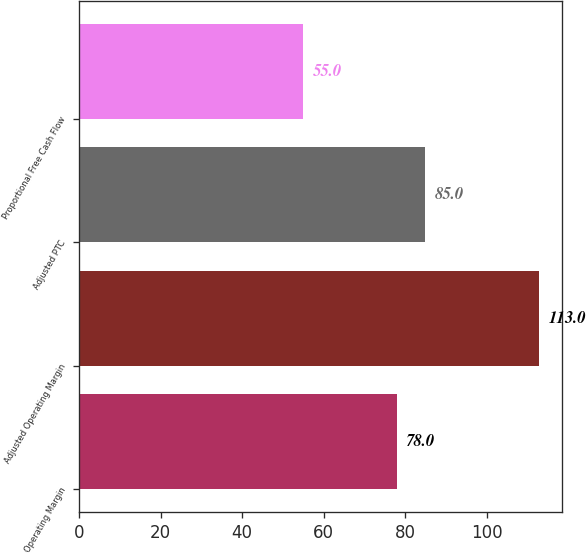Convert chart. <chart><loc_0><loc_0><loc_500><loc_500><bar_chart><fcel>Operating Margin<fcel>Adjusted Operating Margin<fcel>Adjusted PTC<fcel>Proportional Free Cash Flow<nl><fcel>78<fcel>113<fcel>85<fcel>55<nl></chart> 